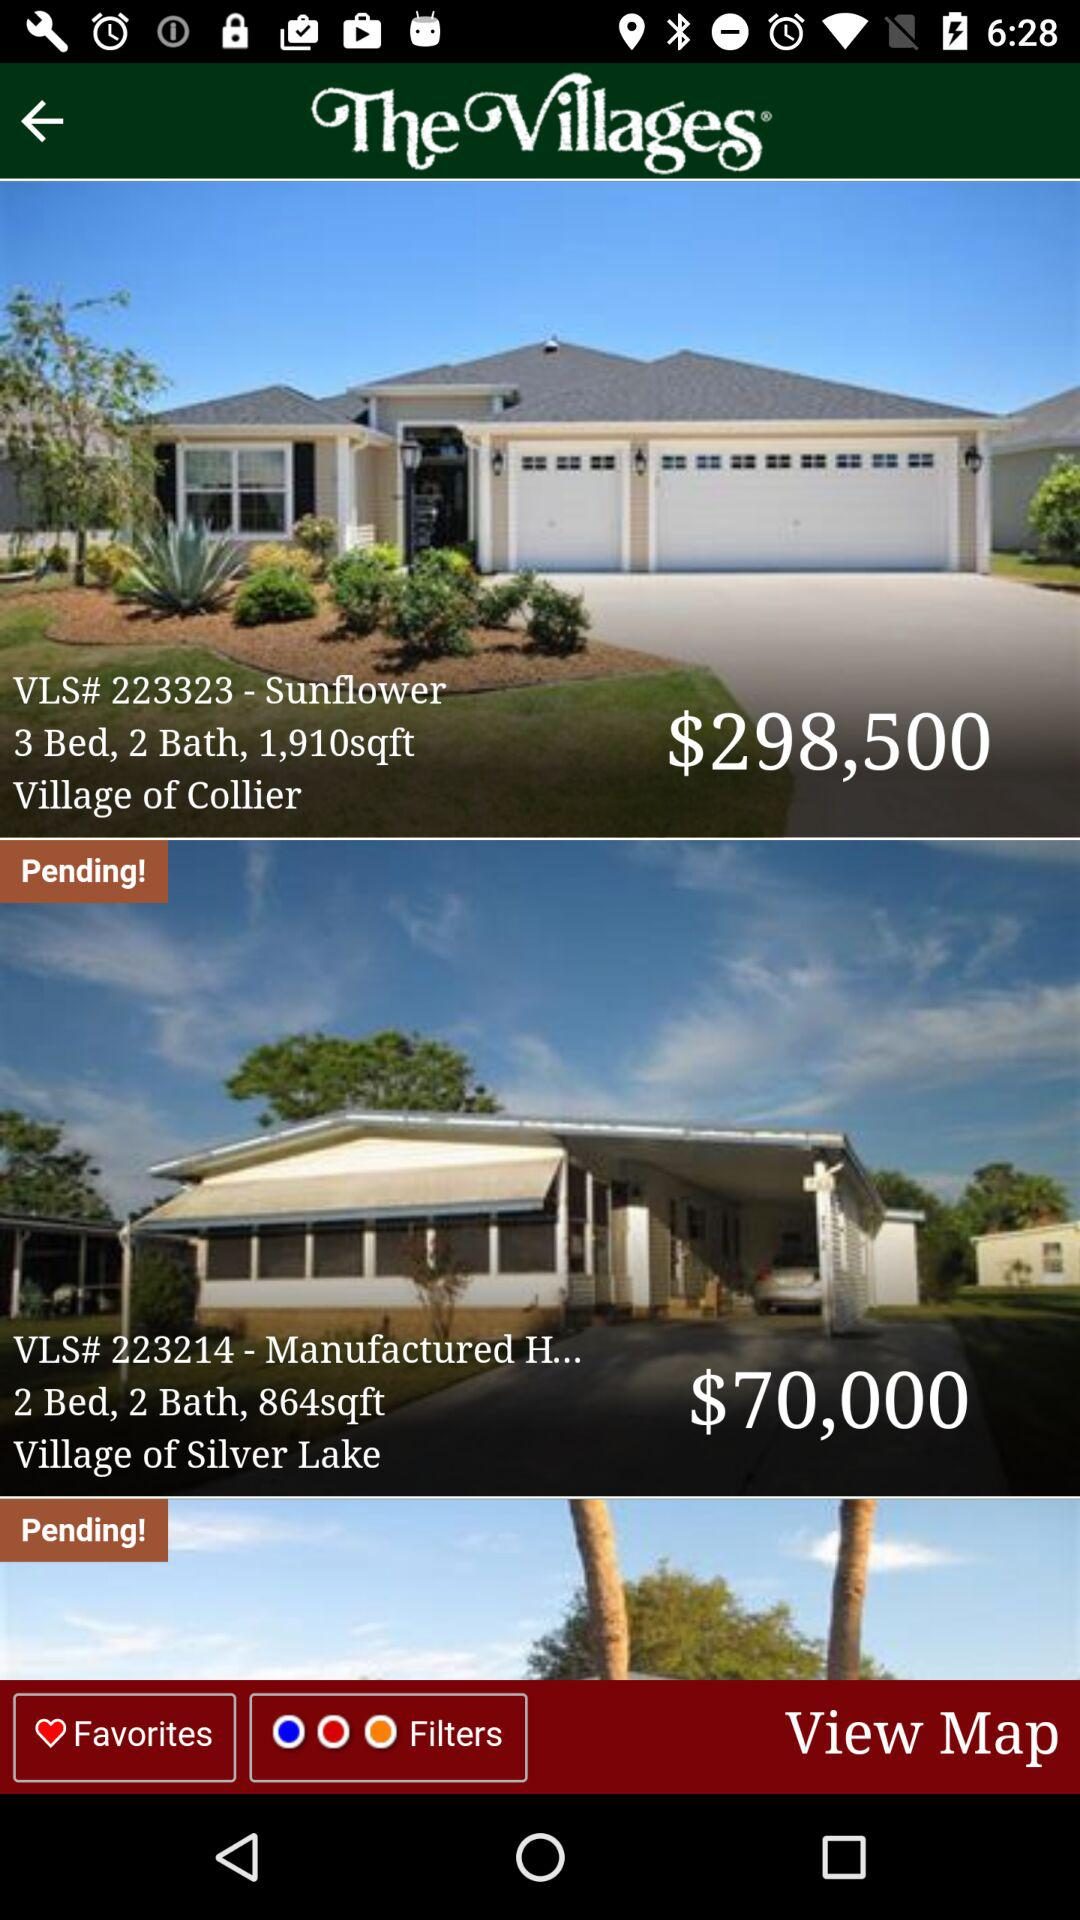What is the location of Village of collier?
When the provided information is insufficient, respond with <no answer>. <no answer> 